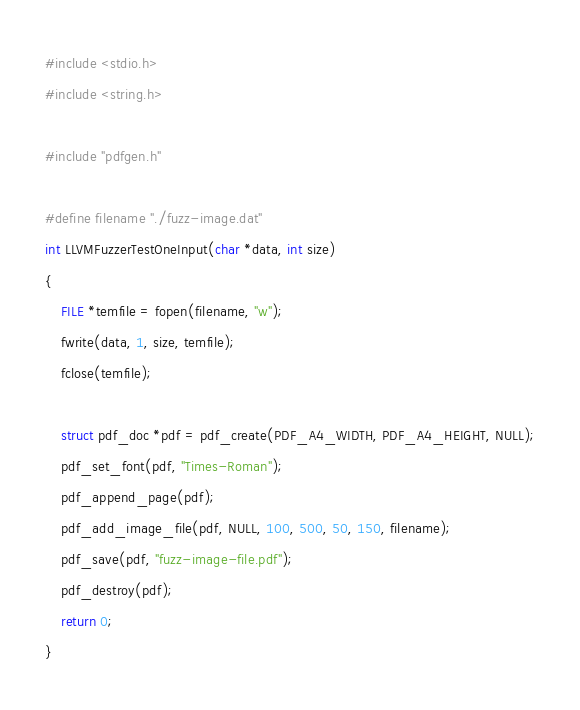Convert code to text. <code><loc_0><loc_0><loc_500><loc_500><_C_>#include <stdio.h>
#include <string.h>

#include "pdfgen.h"

#define filename "./fuzz-image.dat"
int LLVMFuzzerTestOneInput(char *data, int size)
{
    FILE *temfile = fopen(filename, "w");
    fwrite(data, 1, size, temfile);
    fclose(temfile);

    struct pdf_doc *pdf = pdf_create(PDF_A4_WIDTH, PDF_A4_HEIGHT, NULL);
    pdf_set_font(pdf, "Times-Roman");
    pdf_append_page(pdf);
    pdf_add_image_file(pdf, NULL, 100, 500, 50, 150, filename);
    pdf_save(pdf, "fuzz-image-file.pdf");
    pdf_destroy(pdf);
    return 0;
}
</code> 